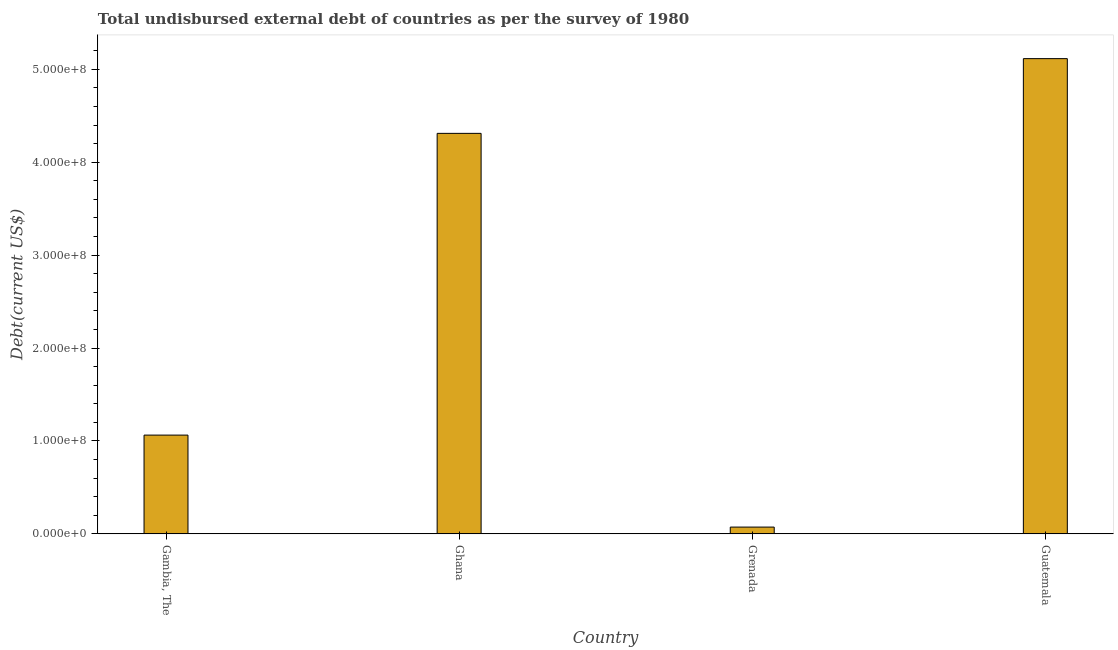Does the graph contain any zero values?
Give a very brief answer. No. Does the graph contain grids?
Your answer should be compact. No. What is the title of the graph?
Give a very brief answer. Total undisbursed external debt of countries as per the survey of 1980. What is the label or title of the X-axis?
Your answer should be compact. Country. What is the label or title of the Y-axis?
Offer a very short reply. Debt(current US$). What is the total debt in Guatemala?
Provide a succinct answer. 5.12e+08. Across all countries, what is the maximum total debt?
Keep it short and to the point. 5.12e+08. Across all countries, what is the minimum total debt?
Provide a succinct answer. 7.29e+06. In which country was the total debt maximum?
Your answer should be compact. Guatemala. In which country was the total debt minimum?
Your response must be concise. Grenada. What is the sum of the total debt?
Your answer should be compact. 1.06e+09. What is the difference between the total debt in Grenada and Guatemala?
Keep it short and to the point. -5.04e+08. What is the average total debt per country?
Give a very brief answer. 2.64e+08. What is the median total debt?
Make the answer very short. 2.69e+08. In how many countries, is the total debt greater than 300000000 US$?
Your response must be concise. 2. What is the ratio of the total debt in Ghana to that in Guatemala?
Your response must be concise. 0.84. Is the difference between the total debt in Gambia, The and Grenada greater than the difference between any two countries?
Your response must be concise. No. What is the difference between the highest and the second highest total debt?
Offer a terse response. 8.04e+07. Is the sum of the total debt in Gambia, The and Grenada greater than the maximum total debt across all countries?
Your answer should be compact. No. What is the difference between the highest and the lowest total debt?
Offer a terse response. 5.04e+08. In how many countries, is the total debt greater than the average total debt taken over all countries?
Offer a terse response. 2. How many bars are there?
Offer a terse response. 4. How many countries are there in the graph?
Keep it short and to the point. 4. What is the difference between two consecutive major ticks on the Y-axis?
Provide a succinct answer. 1.00e+08. What is the Debt(current US$) in Gambia, The?
Offer a terse response. 1.06e+08. What is the Debt(current US$) in Ghana?
Give a very brief answer. 4.31e+08. What is the Debt(current US$) of Grenada?
Offer a terse response. 7.29e+06. What is the Debt(current US$) of Guatemala?
Your answer should be very brief. 5.12e+08. What is the difference between the Debt(current US$) in Gambia, The and Ghana?
Keep it short and to the point. -3.25e+08. What is the difference between the Debt(current US$) in Gambia, The and Grenada?
Ensure brevity in your answer.  9.90e+07. What is the difference between the Debt(current US$) in Gambia, The and Guatemala?
Offer a terse response. -4.05e+08. What is the difference between the Debt(current US$) in Ghana and Grenada?
Ensure brevity in your answer.  4.24e+08. What is the difference between the Debt(current US$) in Ghana and Guatemala?
Your answer should be compact. -8.04e+07. What is the difference between the Debt(current US$) in Grenada and Guatemala?
Your answer should be compact. -5.04e+08. What is the ratio of the Debt(current US$) in Gambia, The to that in Ghana?
Keep it short and to the point. 0.25. What is the ratio of the Debt(current US$) in Gambia, The to that in Grenada?
Your answer should be compact. 14.58. What is the ratio of the Debt(current US$) in Gambia, The to that in Guatemala?
Your answer should be very brief. 0.21. What is the ratio of the Debt(current US$) in Ghana to that in Grenada?
Keep it short and to the point. 59.12. What is the ratio of the Debt(current US$) in Ghana to that in Guatemala?
Offer a terse response. 0.84. What is the ratio of the Debt(current US$) in Grenada to that in Guatemala?
Your answer should be compact. 0.01. 